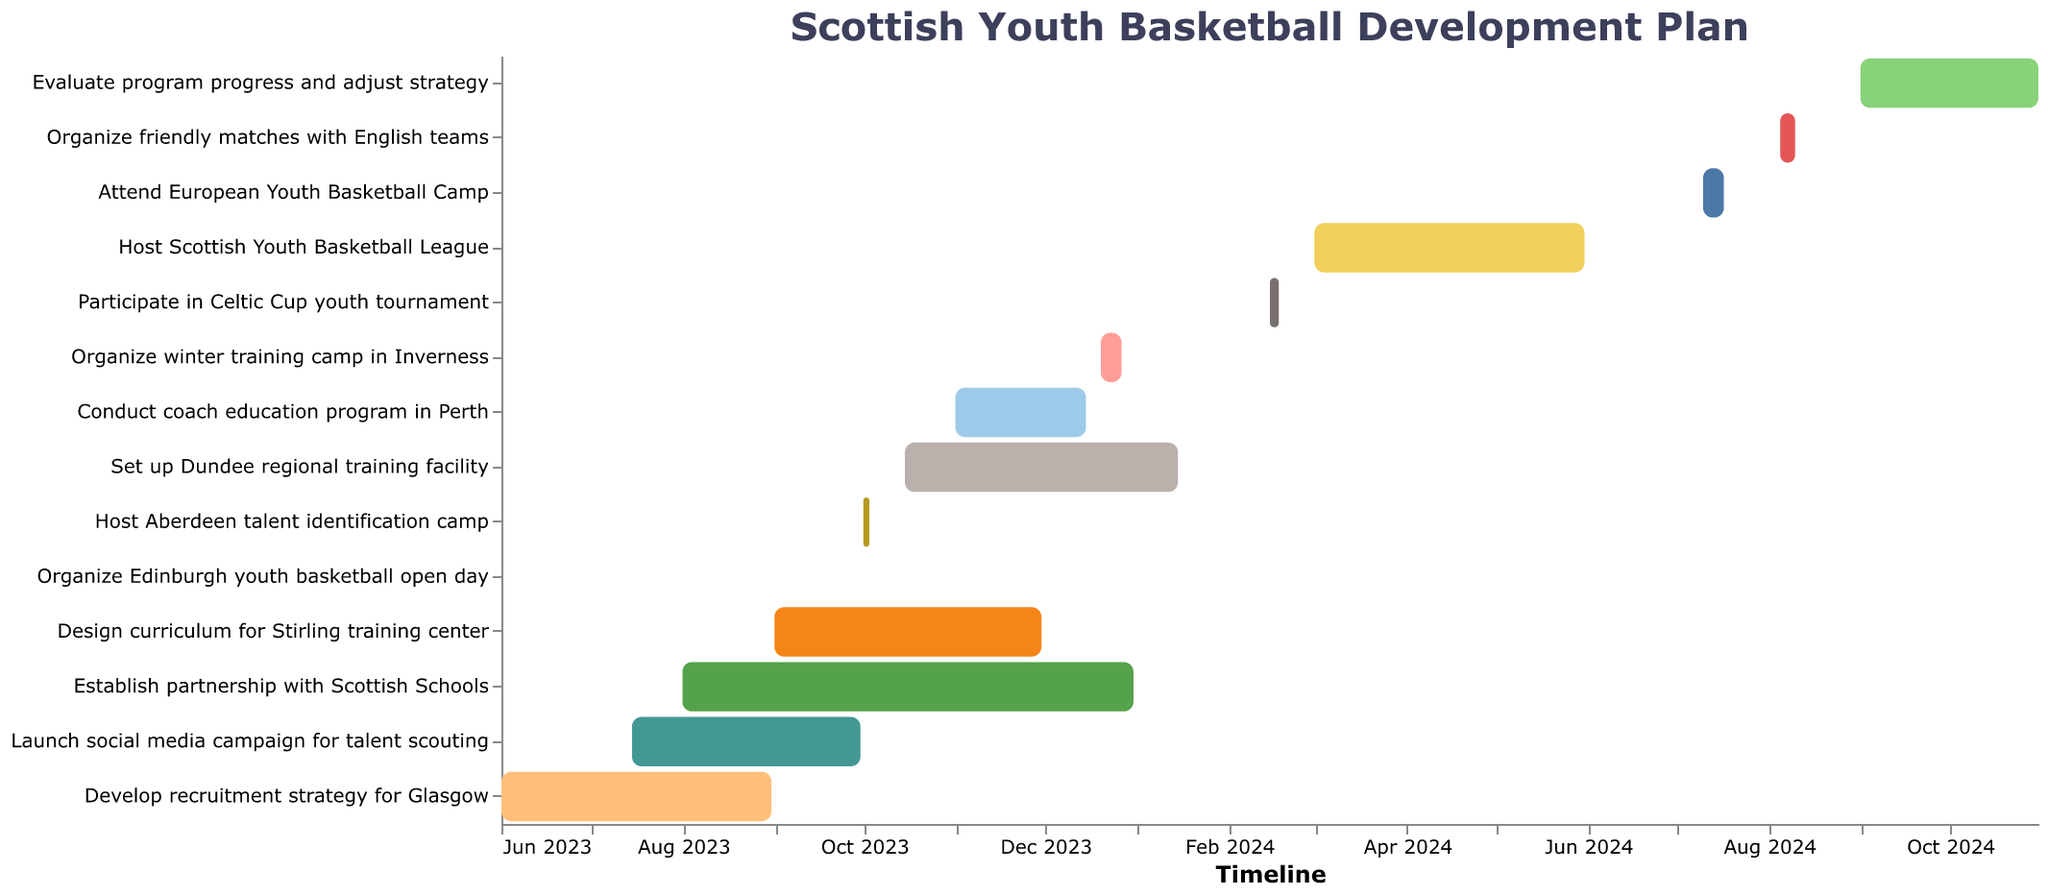What's the title of the Gantt Chart? The title of the Gantt Chart is located at the top of the figure and provides a brief description of the content.
Answer: Scottish Youth Basketball Development Plan When does the social media campaign for talent scouting end? To find the end date of the social media campaign for talent scouting, locate the corresponding bar in the chart and check the rightmost edge.
Answer: 2023-09-30 Which task starts first in the development plan? Identify the bar which starts at the earliest date by looking at the leftmost end of each bar.
Answer: Develop recruitment strategy for Glasgow How long is the "Set up Dundee regional training facility" task planned to last? Calculate the duration by subtracting the start date from the end date of the "Set up Dundee regional training facility" task.
Answer: 3 months Which tasks overlap with the "Conduct coach education program in Perth"? Find the time frame for "Conduct coach education program in Perth" (2023-11-01 to 2023-12-15) and identify other tasks that share any part of this time frame.
Answer: Design curriculum for Stirling training center, Establish partnership with Scottish Schools How many tasks are planned to be completed by the end of 2023? Identify the bars that end before or on 2023-12-31 by checking the rightmost edge of each bar. Count these tasks.
Answer: 8 What is the duration of the "Participate in Celtic Cup youth tournament" task? Calculate the difference between the end date (2024-02-18) and the start date (2024-02-15).
Answer: 3 days Which task has the shortest duration? Locate the bar with the least distance between the start and end dates in the Gantt Chart.
Answer: Organize Edinburgh youth basketball open day How many tasks will still be ongoing at the start of January 2024? Find tasks whose end dates are later than 2024-01-01. Count these tasks.
Answer: 4 Which tasks are scheduled after the "Host Scottish Youth Basketball League"? Identify the tasks starting after 2024-05-31, the end date of "Host Scottish Youth Basketball League".
Answer: Attend European Youth Basketball Camp, Organize friendly matches with English teams, Evaluate program progress and adjust strategy 